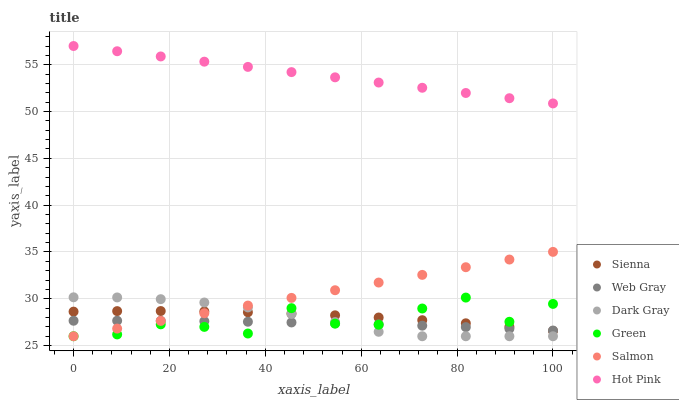Does Web Gray have the minimum area under the curve?
Answer yes or no. Yes. Does Hot Pink have the maximum area under the curve?
Answer yes or no. Yes. Does Hot Pink have the minimum area under the curve?
Answer yes or no. No. Does Web Gray have the maximum area under the curve?
Answer yes or no. No. Is Hot Pink the smoothest?
Answer yes or no. Yes. Is Green the roughest?
Answer yes or no. Yes. Is Web Gray the smoothest?
Answer yes or no. No. Is Web Gray the roughest?
Answer yes or no. No. Does Dark Gray have the lowest value?
Answer yes or no. Yes. Does Web Gray have the lowest value?
Answer yes or no. No. Does Hot Pink have the highest value?
Answer yes or no. Yes. Does Web Gray have the highest value?
Answer yes or no. No. Is Salmon less than Hot Pink?
Answer yes or no. Yes. Is Hot Pink greater than Dark Gray?
Answer yes or no. Yes. Does Web Gray intersect Sienna?
Answer yes or no. Yes. Is Web Gray less than Sienna?
Answer yes or no. No. Is Web Gray greater than Sienna?
Answer yes or no. No. Does Salmon intersect Hot Pink?
Answer yes or no. No. 